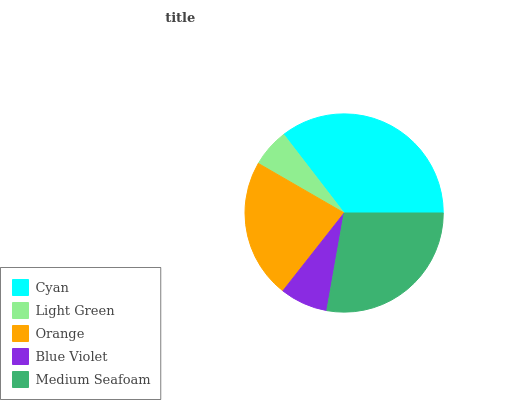Is Light Green the minimum?
Answer yes or no. Yes. Is Cyan the maximum?
Answer yes or no. Yes. Is Orange the minimum?
Answer yes or no. No. Is Orange the maximum?
Answer yes or no. No. Is Orange greater than Light Green?
Answer yes or no. Yes. Is Light Green less than Orange?
Answer yes or no. Yes. Is Light Green greater than Orange?
Answer yes or no. No. Is Orange less than Light Green?
Answer yes or no. No. Is Orange the high median?
Answer yes or no. Yes. Is Orange the low median?
Answer yes or no. Yes. Is Cyan the high median?
Answer yes or no. No. Is Cyan the low median?
Answer yes or no. No. 